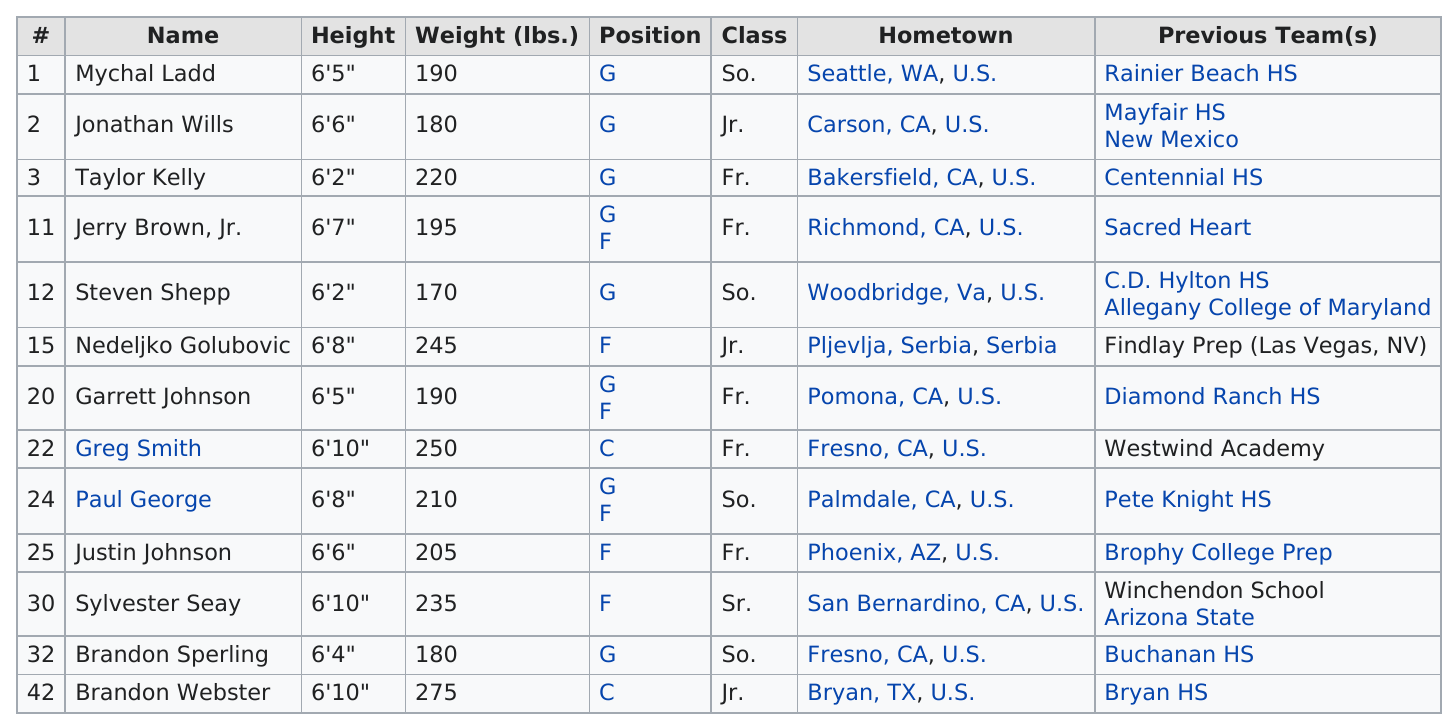Mention a couple of crucial points in this snapshot. Nedelijko Golubovic is the heaviest player, with Sylvester Seay being the second heaviest. Nedeljko Golubovic is the player whose hometown is not located in the United States. It is confirmed that Taylor Kelly is shorter than 6'3", and based on the information provided, it can be deduced that Steven Sheppard is also shorter than 6'3". Five players hail from hometowns located outside of California. Justin Johnson, a forward player, is the shortest among all players. 